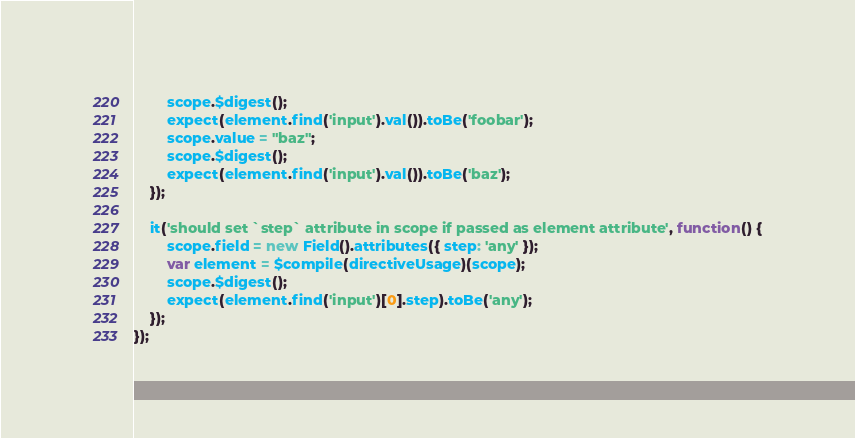Convert code to text. <code><loc_0><loc_0><loc_500><loc_500><_JavaScript_>        scope.$digest();
        expect(element.find('input').val()).toBe('foobar');
        scope.value = "baz";
        scope.$digest();
        expect(element.find('input').val()).toBe('baz');
    });

    it('should set `step` attribute in scope if passed as element attribute', function() {
        scope.field = new Field().attributes({ step: 'any' });
        var element = $compile(directiveUsage)(scope);
        scope.$digest();
        expect(element.find('input')[0].step).toBe('any');
    });
});
</code> 